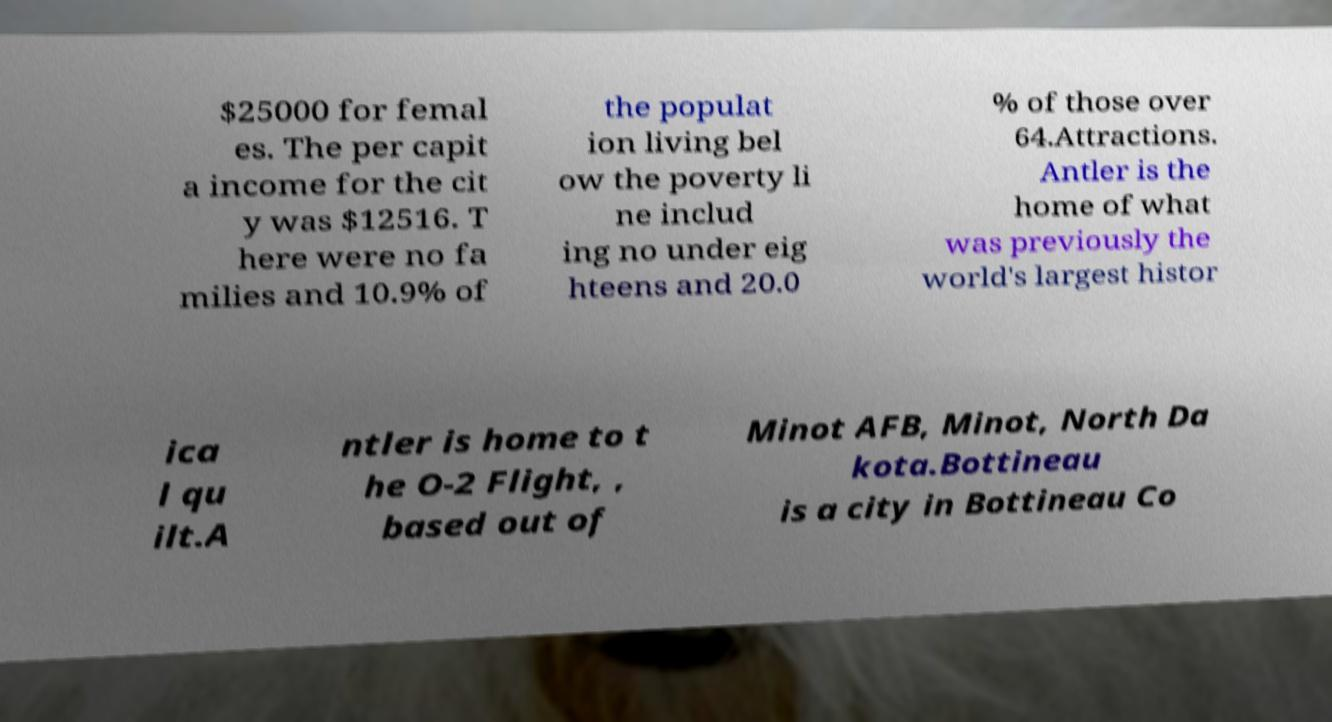Please identify and transcribe the text found in this image. $25000 for femal es. The per capit a income for the cit y was $12516. T here were no fa milies and 10.9% of the populat ion living bel ow the poverty li ne includ ing no under eig hteens and 20.0 % of those over 64.Attractions. Antler is the home of what was previously the world's largest histor ica l qu ilt.A ntler is home to t he O-2 Flight, , based out of Minot AFB, Minot, North Da kota.Bottineau is a city in Bottineau Co 